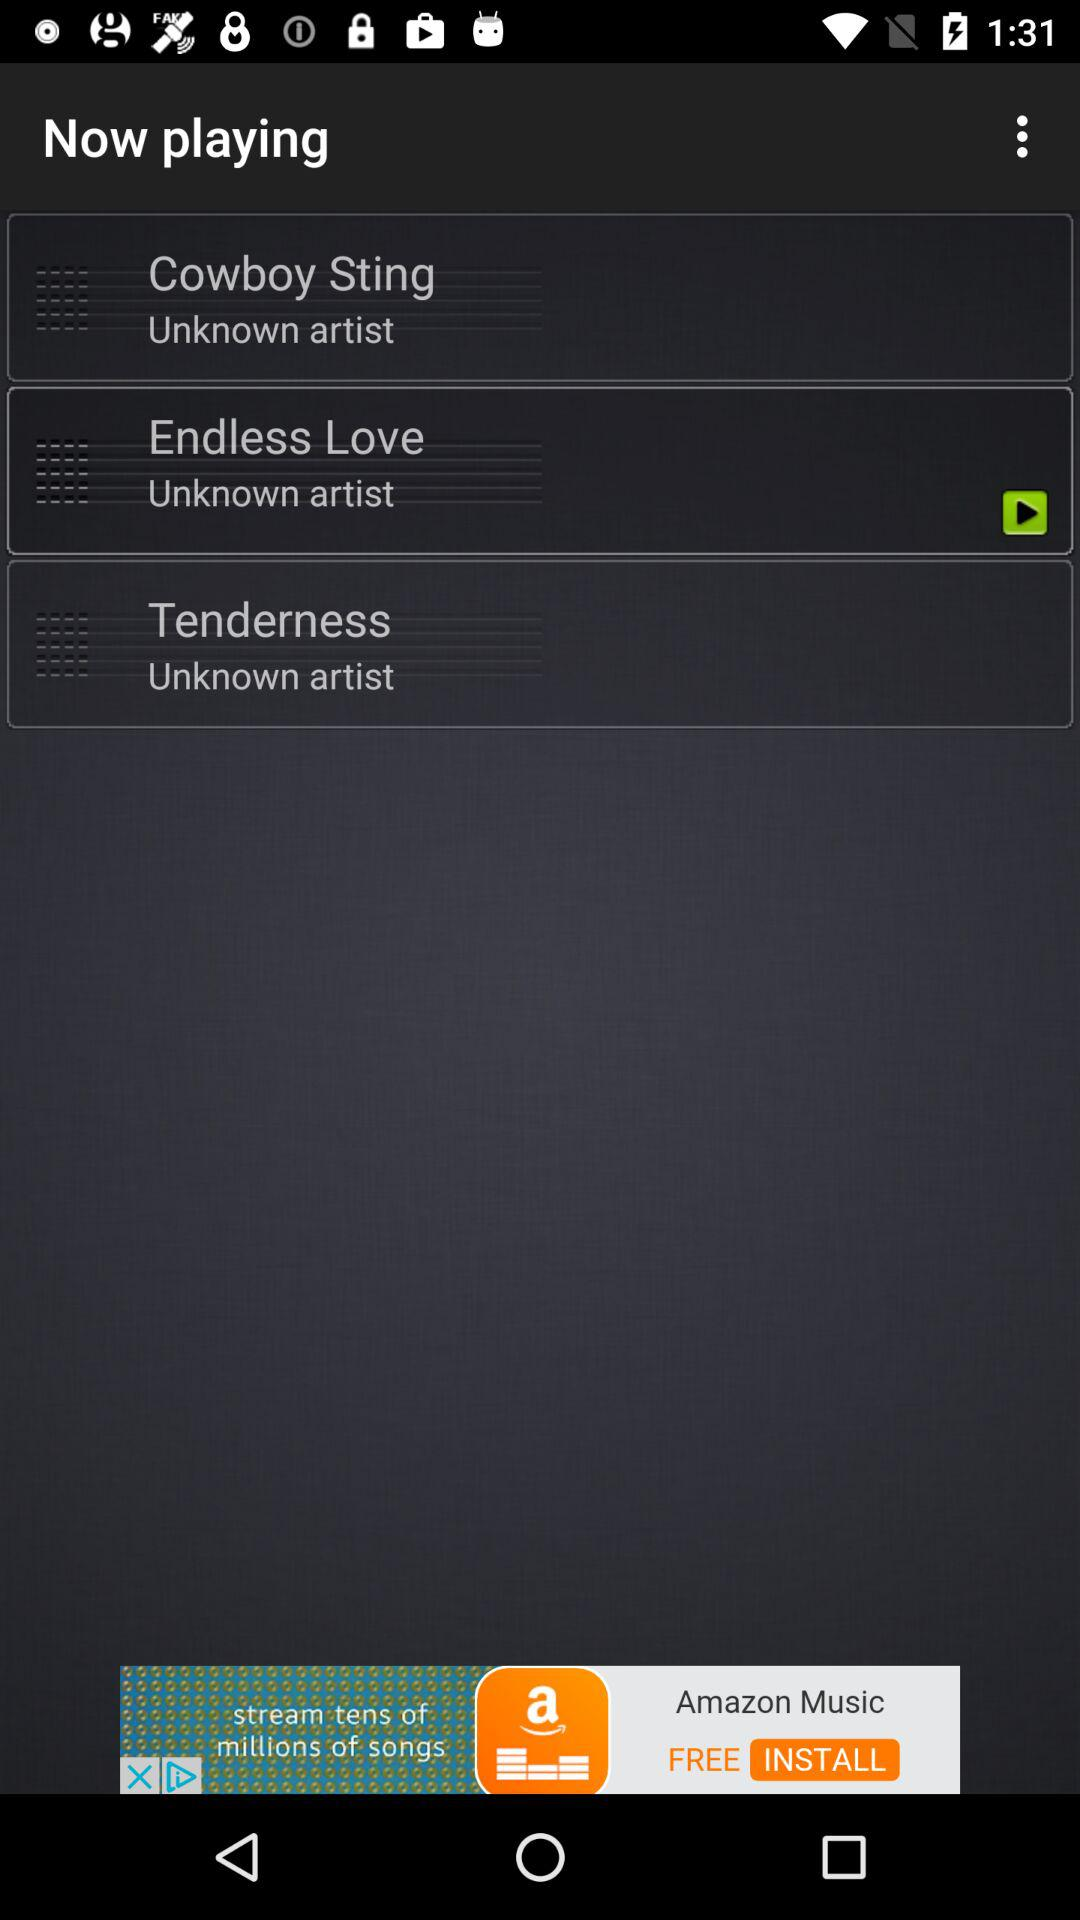Which track was last played? The track last played was "Endless Love". 